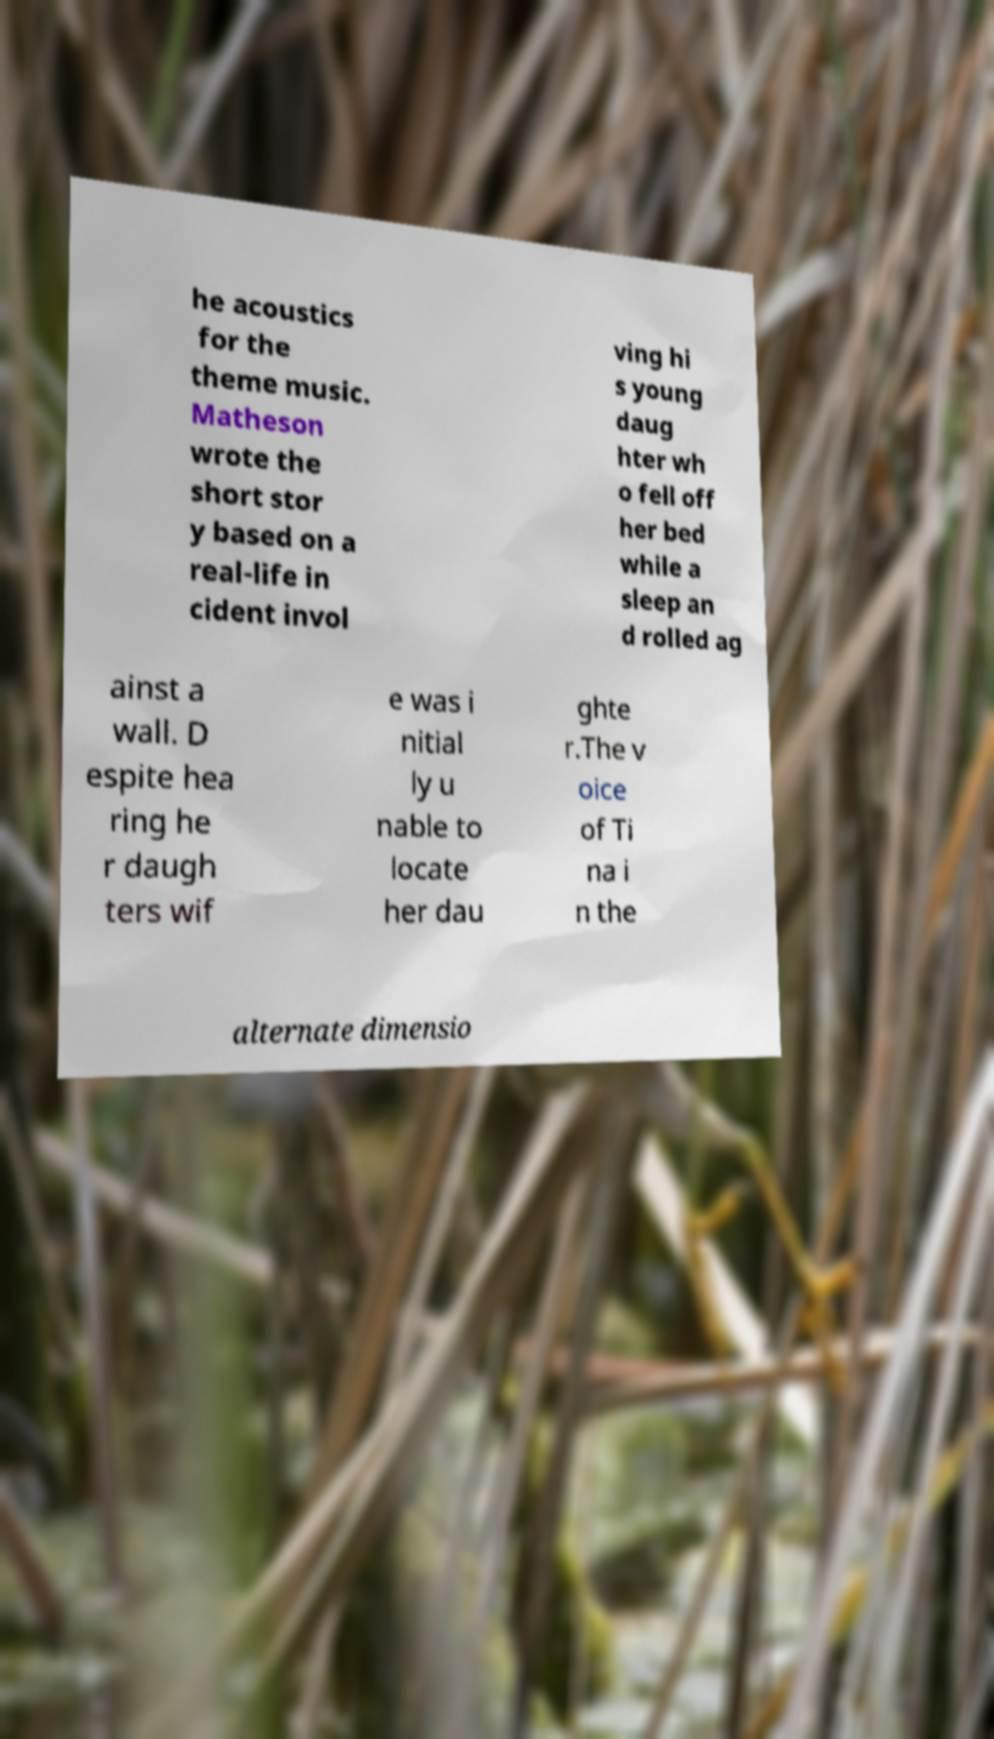Please read and relay the text visible in this image. What does it say? he acoustics for the theme music. Matheson wrote the short stor y based on a real-life in cident invol ving hi s young daug hter wh o fell off her bed while a sleep an d rolled ag ainst a wall. D espite hea ring he r daugh ters wif e was i nitial ly u nable to locate her dau ghte r.The v oice of Ti na i n the alternate dimensio 